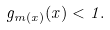<formula> <loc_0><loc_0><loc_500><loc_500>g _ { m ( x ) } ( x ) < 1 .</formula> 